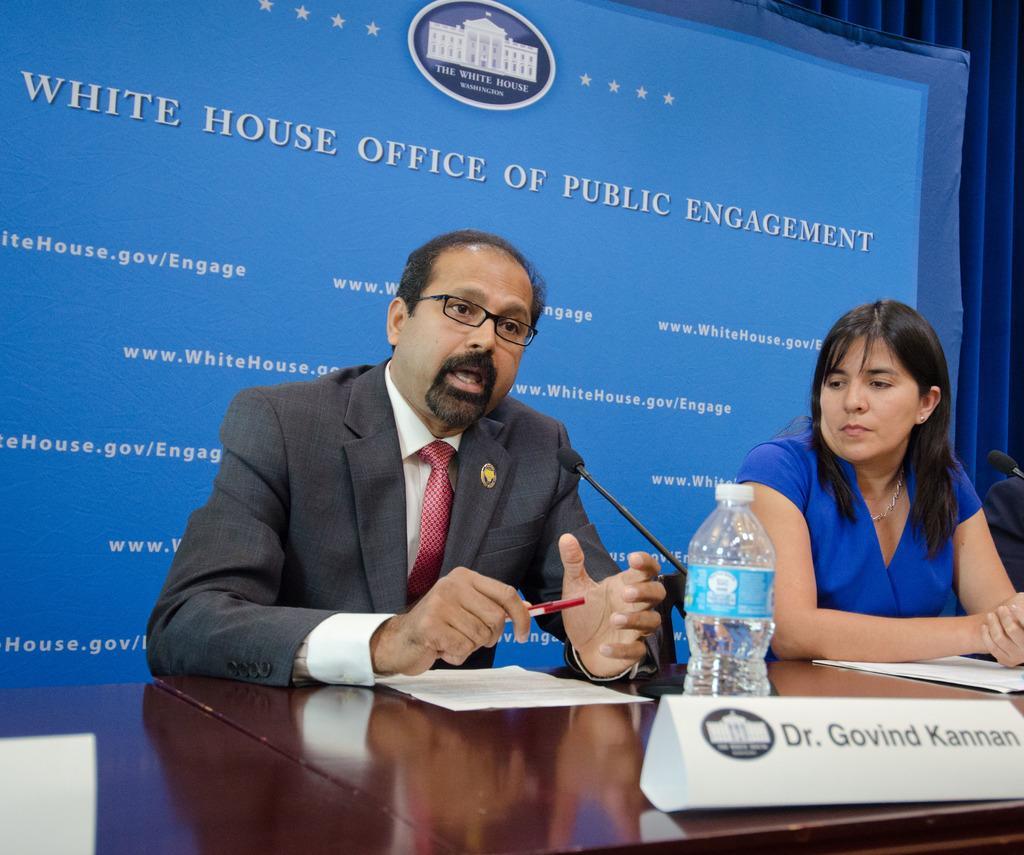Can you describe this image briefly? A man and a woman are at table. The man wears a suit and the woman wears blue dress. There are mice,water bottle and some papers on them. There is screen with title "white house office of public engagement" on it. 